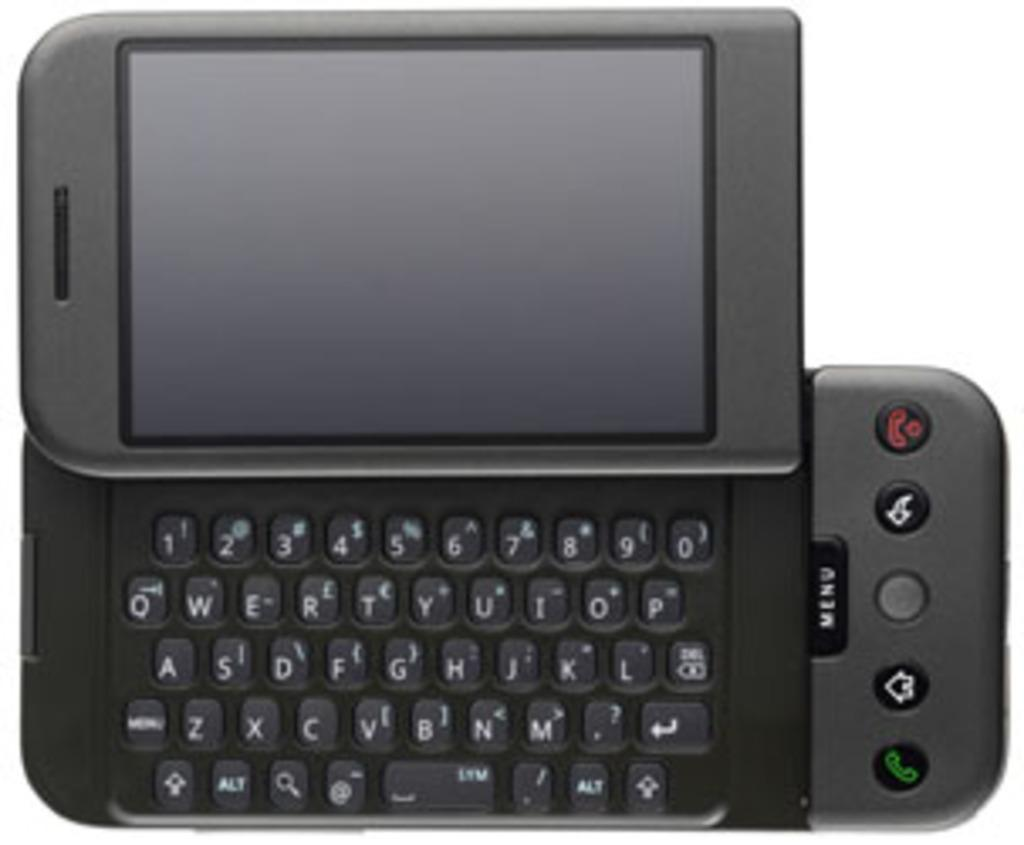<image>
Render a clear and concise summary of the photo. A small mobile device with a black menu button. 